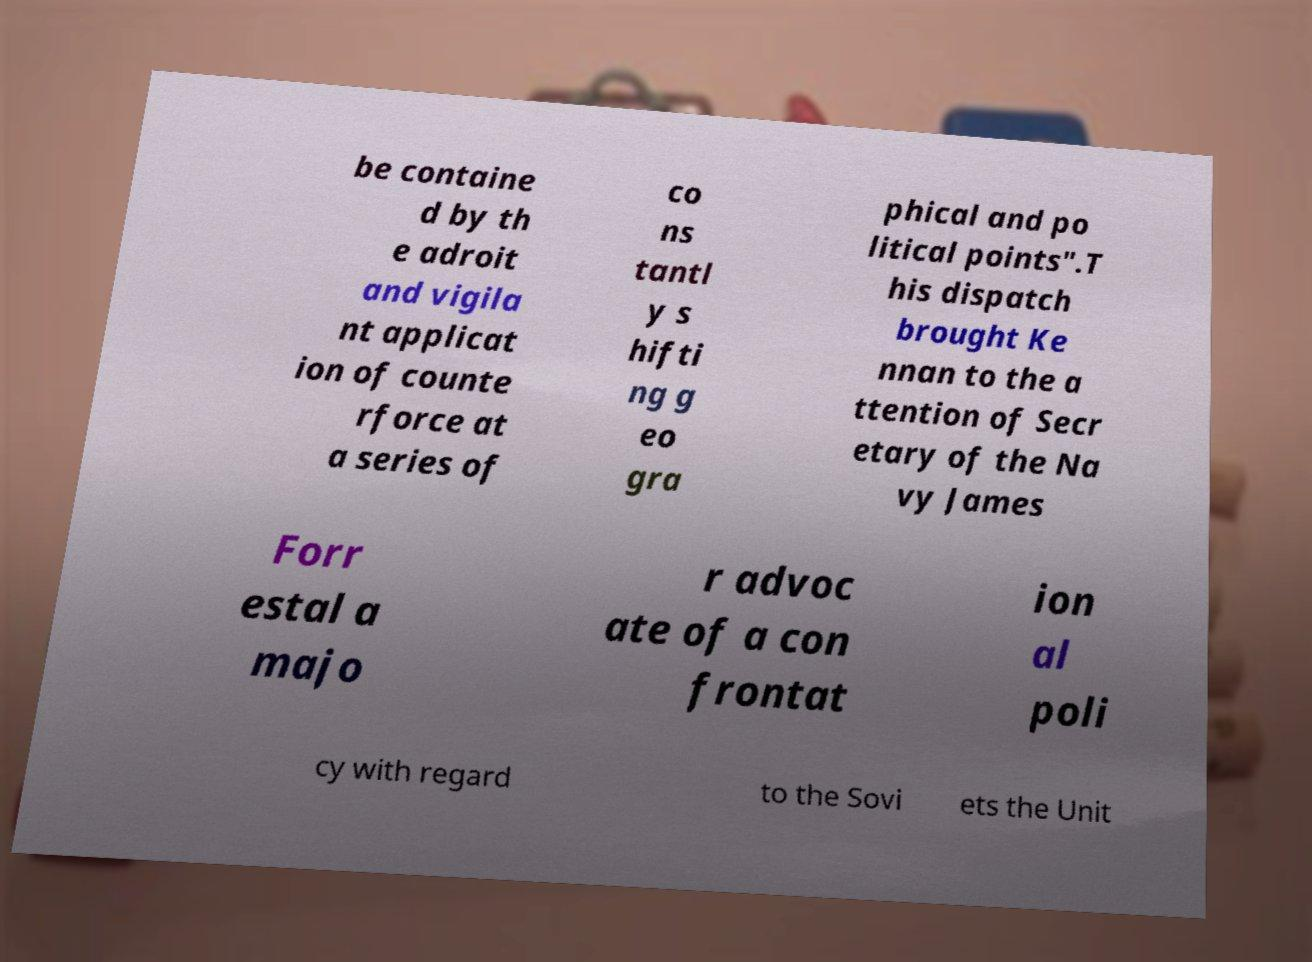Could you extract and type out the text from this image? be containe d by th e adroit and vigila nt applicat ion of counte rforce at a series of co ns tantl y s hifti ng g eo gra phical and po litical points".T his dispatch brought Ke nnan to the a ttention of Secr etary of the Na vy James Forr estal a majo r advoc ate of a con frontat ion al poli cy with regard to the Sovi ets the Unit 